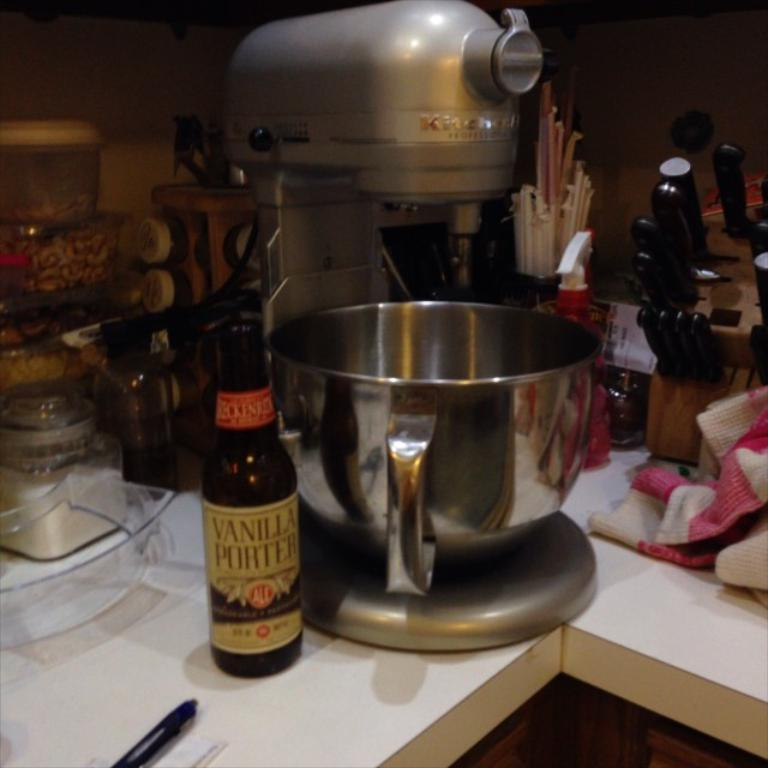What kitchen appliance can be seen in the image? There is a food processor in the image. What type of container is visible in the image? There is a bottle in the image. What is used for storing knives in the image? There is a knife stand in the image. Can you describe any other objects on the table in the image? There are a few other objects on the table in the image, but their specific details are not mentioned in the provided facts. What type of railway is visible in the image? There is no railway present in the image; it features a food processor, a bottle, and a knife stand on a table. Can you describe the spark emitted by the food processor in the image? There is no spark emitted by the food processor in the image, as it is not in use. 